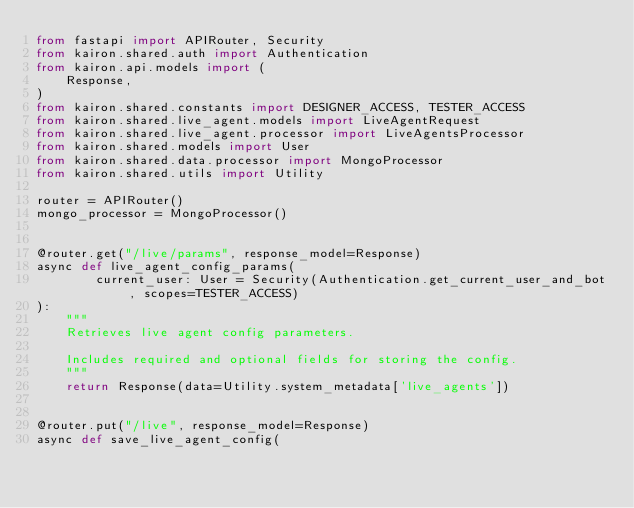Convert code to text. <code><loc_0><loc_0><loc_500><loc_500><_Python_>from fastapi import APIRouter, Security
from kairon.shared.auth import Authentication
from kairon.api.models import (
    Response,
)
from kairon.shared.constants import DESIGNER_ACCESS, TESTER_ACCESS
from kairon.shared.live_agent.models import LiveAgentRequest
from kairon.shared.live_agent.processor import LiveAgentsProcessor
from kairon.shared.models import User
from kairon.shared.data.processor import MongoProcessor
from kairon.shared.utils import Utility

router = APIRouter()
mongo_processor = MongoProcessor()


@router.get("/live/params", response_model=Response)
async def live_agent_config_params(
        current_user: User = Security(Authentication.get_current_user_and_bot, scopes=TESTER_ACCESS)
):
    """
    Retrieves live agent config parameters.

    Includes required and optional fields for storing the config.
    """
    return Response(data=Utility.system_metadata['live_agents'])


@router.put("/live", response_model=Response)
async def save_live_agent_config(</code> 